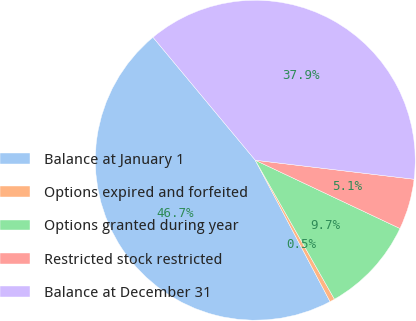Convert chart. <chart><loc_0><loc_0><loc_500><loc_500><pie_chart><fcel>Balance at January 1<fcel>Options expired and forfeited<fcel>Options granted during year<fcel>Restricted stock restricted<fcel>Balance at December 31<nl><fcel>46.7%<fcel>0.5%<fcel>9.74%<fcel>5.12%<fcel>37.94%<nl></chart> 